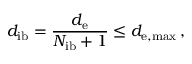<formula> <loc_0><loc_0><loc_500><loc_500>d _ { i b } = \frac { d _ { e } } { N _ { i b } + 1 } \leq d _ { e , \max } \, ,</formula> 